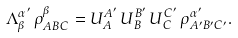<formula> <loc_0><loc_0><loc_500><loc_500>\Lambda ^ { { \alpha } ^ { \prime } } _ { \beta } \, \rho ^ { \beta } _ { A B C } = U ^ { A ^ { \prime } } _ { A } \, U ^ { B ^ { \prime } } _ { B } \, U ^ { C ^ { \prime } } _ { C } \, \rho ^ { { \alpha } ^ { \prime } } _ { A ^ { \prime } B ^ { \prime } C ^ { \prime } } .</formula> 